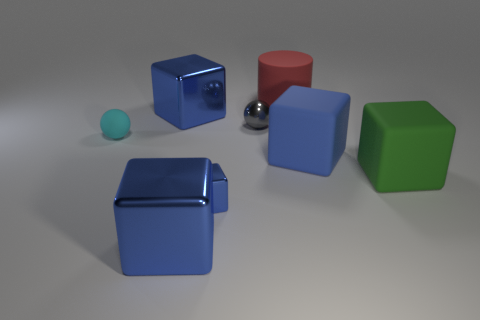How many blue cubes must be subtracted to get 1 blue cubes? 3 Subtract all green spheres. How many blue blocks are left? 4 Subtract all blue blocks. How many blocks are left? 1 Subtract all green blocks. How many blocks are left? 4 Add 1 tiny gray objects. How many objects exist? 9 Subtract all cylinders. How many objects are left? 7 Subtract all green blocks. Subtract all cyan cylinders. How many blocks are left? 4 Subtract all small gray balls. Subtract all gray shiny objects. How many objects are left? 6 Add 1 small spheres. How many small spheres are left? 3 Add 5 small cubes. How many small cubes exist? 6 